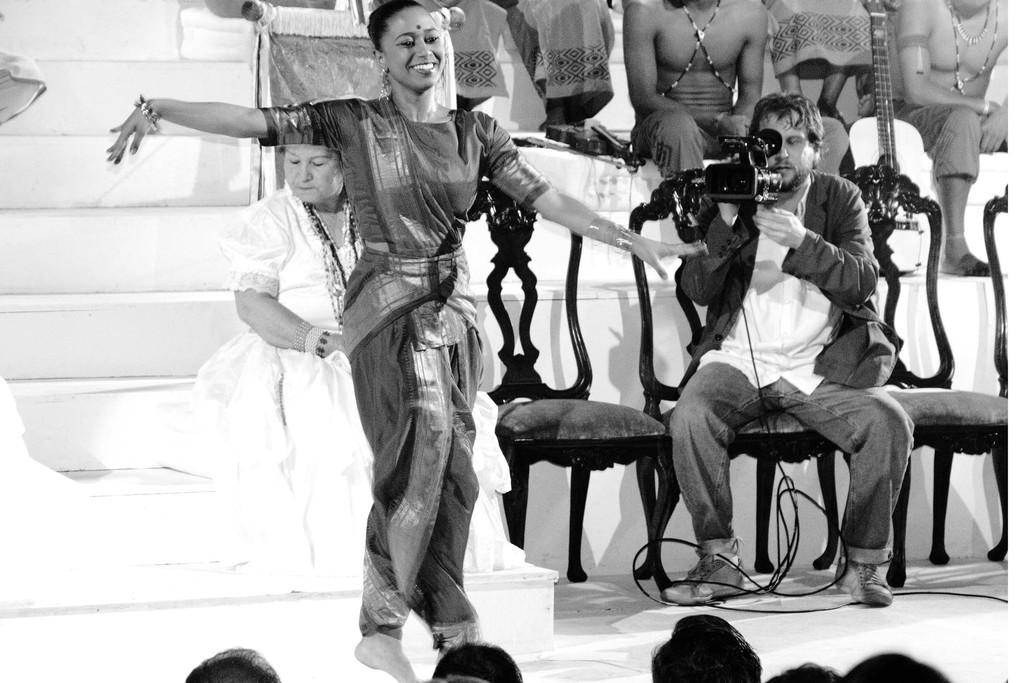What is the woman in the image doing? The woman is dancing in the image. How does the woman appear to be feeling while dancing? The woman has a smile on her face, indicating that she is happy or enjoying herself. What are the other people in the image doing? The other people are seated behind the dancing woman. Who is capturing the moment in the image? There is a person holding a camera behind the woman. What type of rail can be seen in the image? There is no rail present in the image. How many passengers are seated in the box in the image? There is no box or passengers present in the image. 